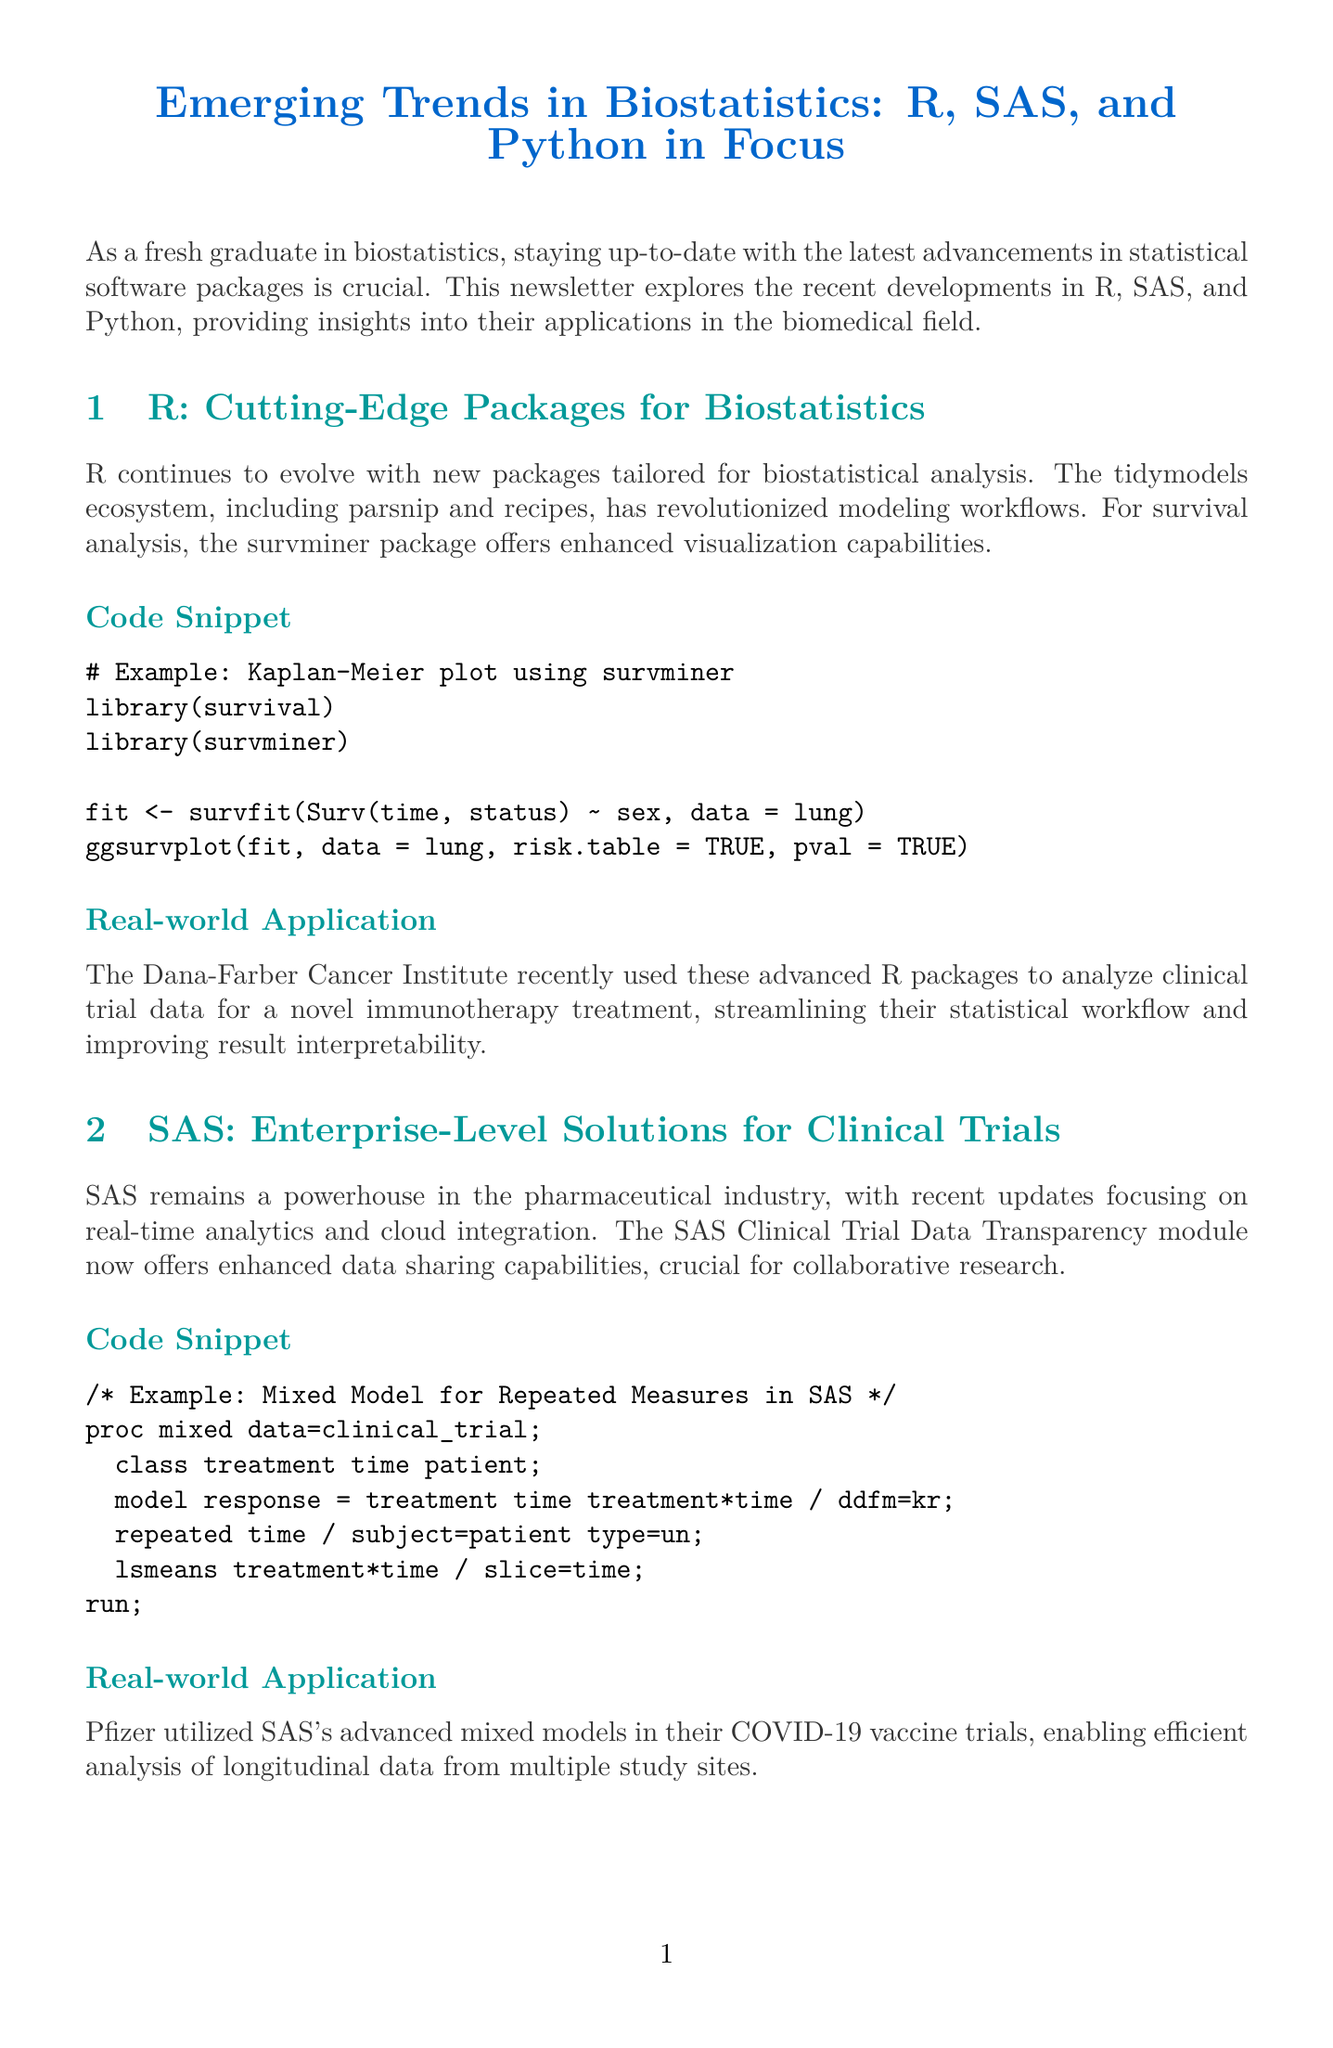What is the title of the newsletter? The title is clearly stated at the beginning of the document.
Answer: Emerging Trends in Biostatistics: R, SAS, and Python in Focus Who recently used advanced R packages for clinical trial analysis? The document provides a specific example of an organization that applied R's capabilities.
Answer: Dana-Farber Cancer Institute What statistical technique is demonstrated in the Python code snippet? The code example shows a specific model used in biostatistics highlighted in the Python section.
Answer: Cox Proportional Hazards model What is the primary focus of SAS updates mentioned in the document? The document indicates the main improvements made in SAS relevant to its industry application.
Answer: Real-time analytics Which platform has an excellent integration with machine learning? The comparative analysis section highlights the strengths of each statistical software.
Answer: Python What is the learning curve rating for SAS? The table provides a straightforward assessment of the learning curve associated with each software.
Answer: Steep What future trend involves natural language processing? The future trends section lists key points for emerging developments in biostatistics.
Answer: Integration of natural language processing for literature review and meta-analysis Which of the three software packages is open source? The comparative analysis section includes information about the status of each software's source code.
Answer: R and Python What real-world application used SAS's mixed models? The document describes a specific project where SAS was utilized effectively.
Answer: Pfizer COVID-19 vaccine trials 